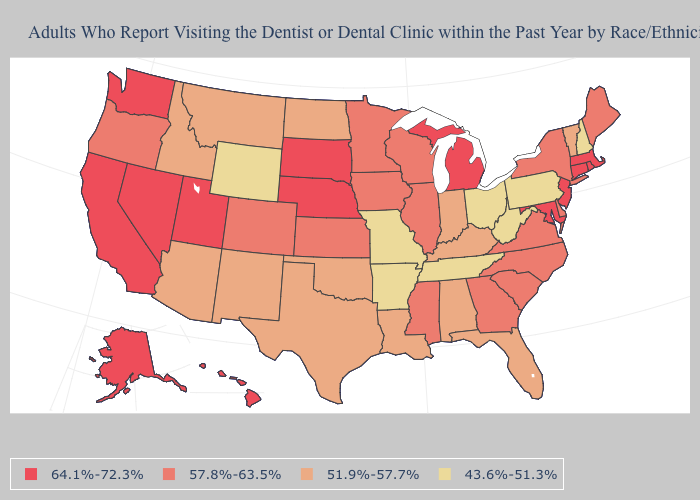Which states have the highest value in the USA?
Keep it brief. Alaska, California, Connecticut, Hawaii, Maryland, Massachusetts, Michigan, Nebraska, Nevada, New Jersey, Rhode Island, South Dakota, Utah, Washington. Name the states that have a value in the range 43.6%-51.3%?
Be succinct. Arkansas, Missouri, New Hampshire, Ohio, Pennsylvania, Tennessee, West Virginia, Wyoming. Which states have the lowest value in the MidWest?
Short answer required. Missouri, Ohio. Among the states that border North Carolina , which have the highest value?
Be succinct. Georgia, South Carolina, Virginia. Name the states that have a value in the range 64.1%-72.3%?
Answer briefly. Alaska, California, Connecticut, Hawaii, Maryland, Massachusetts, Michigan, Nebraska, Nevada, New Jersey, Rhode Island, South Dakota, Utah, Washington. How many symbols are there in the legend?
Concise answer only. 4. Is the legend a continuous bar?
Write a very short answer. No. Among the states that border Mississippi , does Alabama have the lowest value?
Be succinct. No. What is the highest value in the Northeast ?
Be succinct. 64.1%-72.3%. What is the value of Texas?
Write a very short answer. 51.9%-57.7%. What is the value of Colorado?
Concise answer only. 57.8%-63.5%. What is the lowest value in the South?
Keep it brief. 43.6%-51.3%. Among the states that border Maryland , does West Virginia have the highest value?
Give a very brief answer. No. Name the states that have a value in the range 51.9%-57.7%?
Short answer required. Alabama, Arizona, Florida, Idaho, Indiana, Kentucky, Louisiana, Montana, New Mexico, North Dakota, Oklahoma, Texas, Vermont. Among the states that border Kansas , does Colorado have the lowest value?
Concise answer only. No. 